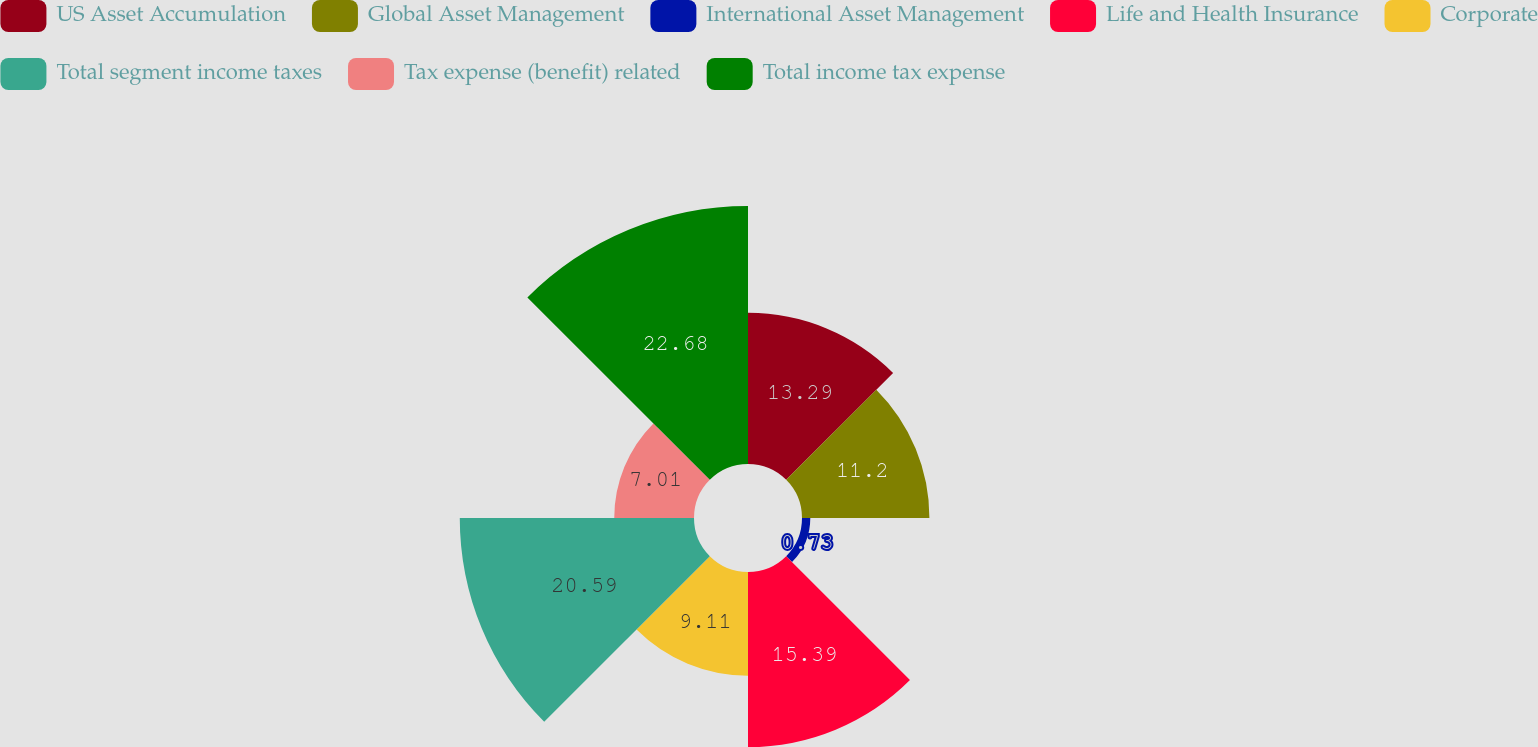<chart> <loc_0><loc_0><loc_500><loc_500><pie_chart><fcel>US Asset Accumulation<fcel>Global Asset Management<fcel>International Asset Management<fcel>Life and Health Insurance<fcel>Corporate<fcel>Total segment income taxes<fcel>Tax expense (benefit) related<fcel>Total income tax expense<nl><fcel>13.29%<fcel>11.2%<fcel>0.73%<fcel>15.39%<fcel>9.11%<fcel>20.59%<fcel>7.01%<fcel>22.68%<nl></chart> 